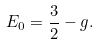Convert formula to latex. <formula><loc_0><loc_0><loc_500><loc_500>E _ { 0 } = \frac { 3 } { 2 } - g .</formula> 